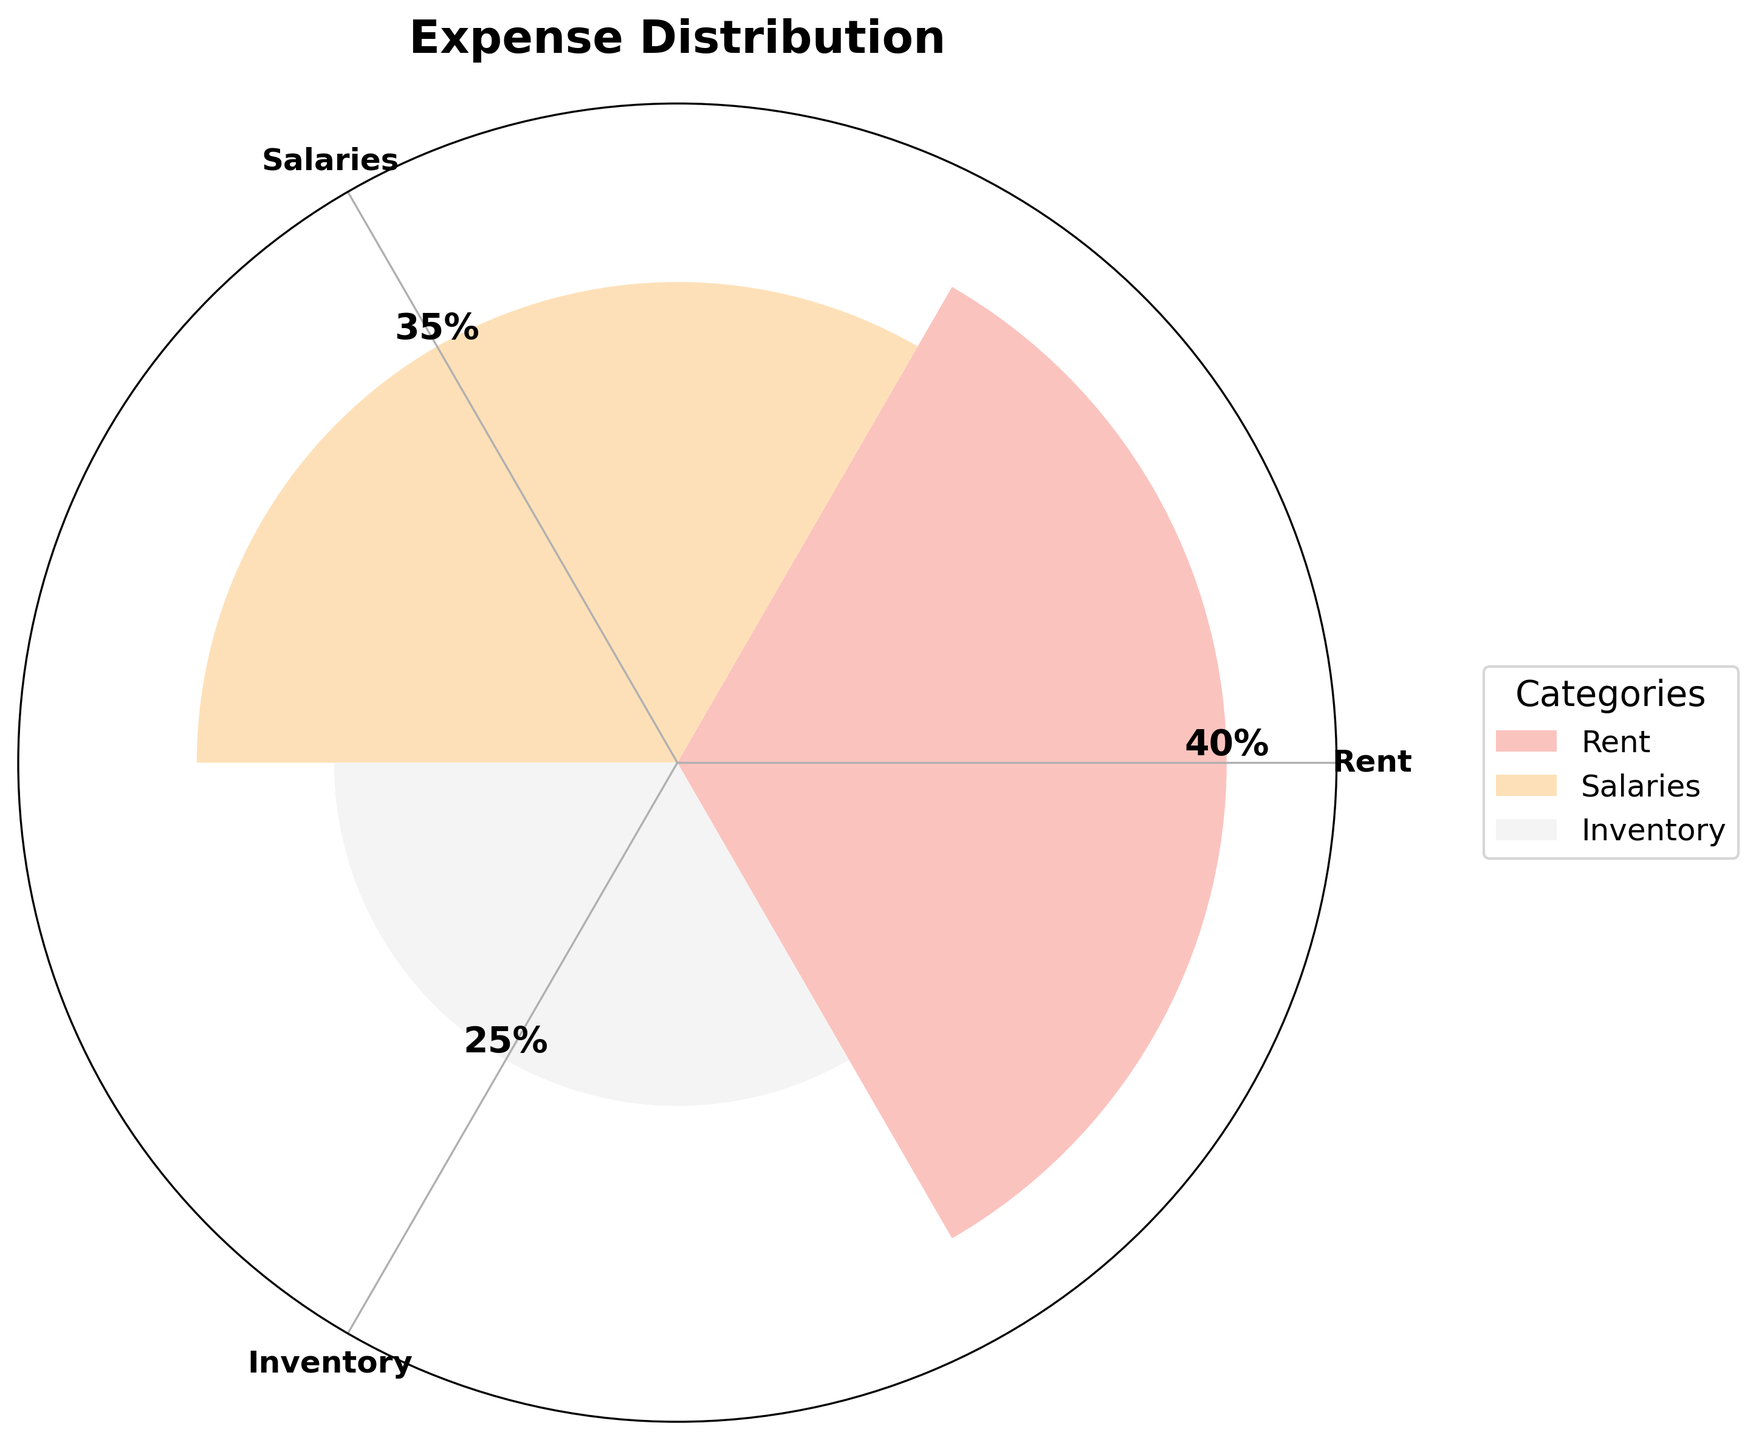What is the title of the plot? The title of the plot is written at the top and provides an overview of what the plot is about. The text reads 'Expense Distribution'.
Answer: Expense Distribution Which expense category has the largest percentage? By looking at the height of the bars in the plot, we can see that the bar for 'Rent' is the tallest. The text above the 'Rent' bar also indicates it is 40%.
Answer: Rent What is the percentage for Salaries? The value above the bar labeled 'Salaries' reads 35%, indicating the percentage allocated to salaries.
Answer: 35% What is the difference in percentage between Rent and Inventory? The Rent percentage is 40% and the Inventory percentage is 25%. The difference is 40% - 25%.
Answer: 15% Which two categories combined make up more than half the total expenses? Combining Rent and Salaries: Rent is 40% and Salaries is 35%. Adding these together gives 40% + 35%, which is greater than 50%.
Answer: Rent and Salaries How many categories are displayed in the plot? By counting the number of bars or the number of items in the legend, we can see there are three categories displayed: Rent, Salaries, and Inventory.
Answer: Three Which category has the smallest percentage? The shortest bar indicates the smallest percentage. In this plot, the 'Inventory' bar is the shortest, which is 25%.
Answer: Inventory Are all percentages mutually exclusive? Since the plot shows distinct bars with non-overlapping percentages for Rent, Salaries, and Inventory, we can state that the percentages are mutually exclusive and collectively represent the total expenses.
Answer: Yes What is the total percentage covered by all categories? By summing the percentages of all categories: Rent 40%, Salaries 35%, and Inventory 25%, we get 40% + 35% + 25%.
Answer: 100% Is there any color overlap among the categories? Each category is assigned a distinct color as indicated in the legend, with no overlapping shades.
Answer: No 